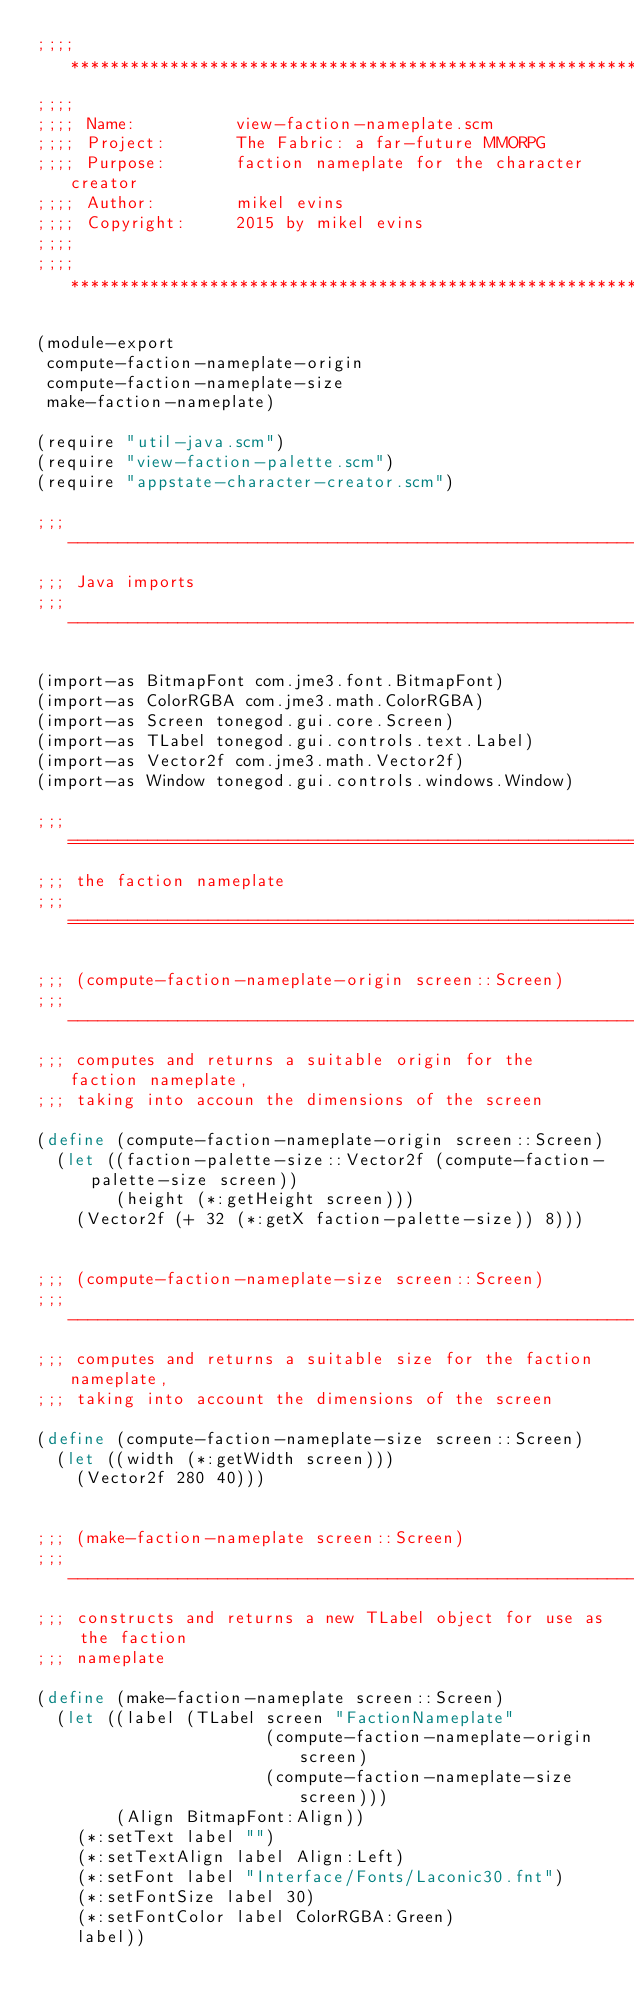Convert code to text. <code><loc_0><loc_0><loc_500><loc_500><_Scheme_>;;;; ***********************************************************************
;;;;
;;;; Name:          view-faction-nameplate.scm
;;;; Project:       The Fabric: a far-future MMORPG
;;;; Purpose:       faction nameplate for the character creator
;;;; Author:        mikel evins
;;;; Copyright:     2015 by mikel evins
;;;;
;;;; ***********************************************************************

(module-export
 compute-faction-nameplate-origin
 compute-faction-nameplate-size
 make-faction-nameplate)

(require "util-java.scm")
(require "view-faction-palette.scm")
(require "appstate-character-creator.scm")

;;; ---------------------------------------------------------------------
;;; Java imports
;;; ---------------------------------------------------------------------

(import-as BitmapFont com.jme3.font.BitmapFont)
(import-as ColorRGBA com.jme3.math.ColorRGBA)
(import-as Screen tonegod.gui.core.Screen)
(import-as TLabel tonegod.gui.controls.text.Label)
(import-as Vector2f com.jme3.math.Vector2f)
(import-as Window tonegod.gui.controls.windows.Window)

;;; =====================================================================
;;; the faction nameplate
;;; =====================================================================

;;; (compute-faction-nameplate-origin screen::Screen)
;;; ---------------------------------------------------------------------
;;; computes and returns a suitable origin for the faction nameplate,
;;; taking into accoun the dimensions of the screen

(define (compute-faction-nameplate-origin screen::Screen)
  (let ((faction-palette-size::Vector2f (compute-faction-palette-size screen))
        (height (*:getHeight screen)))
    (Vector2f (+ 32 (*:getX faction-palette-size)) 8)))


;;; (compute-faction-nameplate-size screen::Screen)
;;; ---------------------------------------------------------------------
;;; computes and returns a suitable size for the faction nameplate,
;;; taking into account the dimensions of the screen

(define (compute-faction-nameplate-size screen::Screen)
  (let ((width (*:getWidth screen)))
    (Vector2f 280 40)))


;;; (make-faction-nameplate screen::Screen)
;;; ---------------------------------------------------------------------
;;; constructs and returns a new TLabel object for use as the faction
;;; nameplate

(define (make-faction-nameplate screen::Screen)
  (let ((label (TLabel screen "FactionNameplate"
                       (compute-faction-nameplate-origin screen)
                       (compute-faction-nameplate-size screen)))
        (Align BitmapFont:Align))
    (*:setText label "")
    (*:setTextAlign label Align:Left)
    (*:setFont label "Interface/Fonts/Laconic30.fnt")
    (*:setFontSize label 30)
    (*:setFontColor label ColorRGBA:Green)
    label))

</code> 